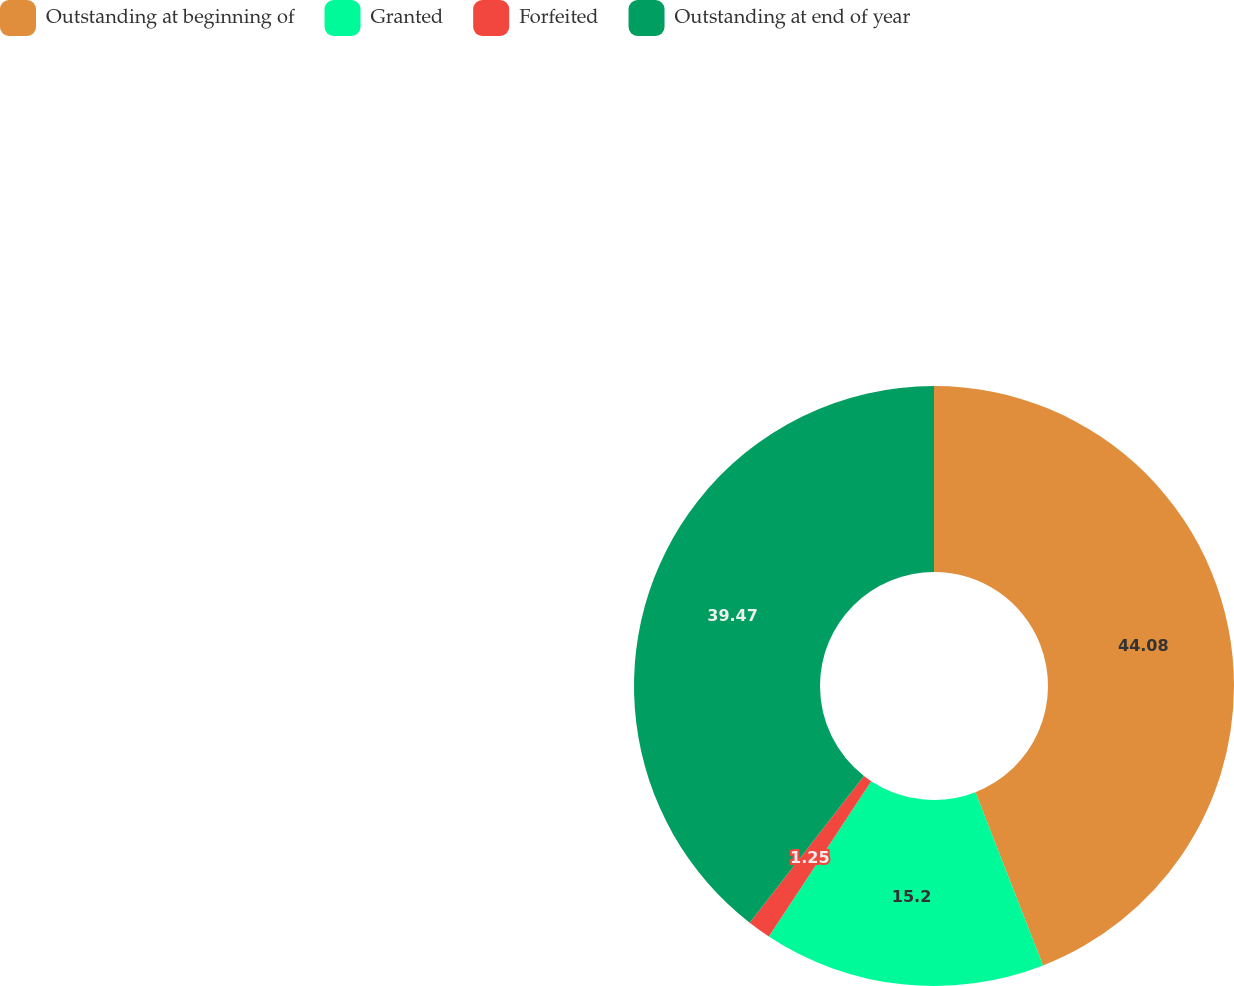Convert chart to OTSL. <chart><loc_0><loc_0><loc_500><loc_500><pie_chart><fcel>Outstanding at beginning of<fcel>Granted<fcel>Forfeited<fcel>Outstanding at end of year<nl><fcel>44.08%<fcel>15.2%<fcel>1.25%<fcel>39.47%<nl></chart> 